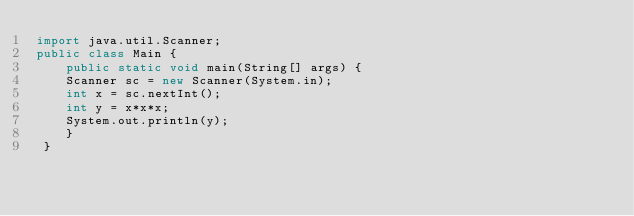<code> <loc_0><loc_0><loc_500><loc_500><_Java_>import java.util.Scanner;
public class Main {
    public static void main(String[] args) {
    Scanner sc = new Scanner(System.in);
    int x = sc.nextInt();
    int y = x*x*x;
    System.out.println(y);
    }
 }
</code> 